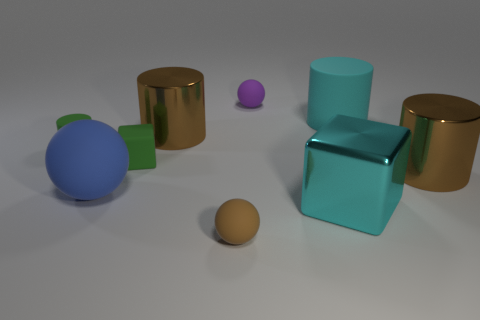Subtract all green cylinders. How many cylinders are left? 3 Subtract 2 balls. How many balls are left? 1 Subtract all green blocks. How many blocks are left? 1 Subtract all red blocks. Subtract all cyan balls. How many blocks are left? 2 Subtract all gray cylinders. How many purple balls are left? 1 Subtract all tiny cylinders. Subtract all big brown shiny objects. How many objects are left? 6 Add 6 green rubber things. How many green rubber things are left? 8 Add 2 brown balls. How many brown balls exist? 3 Subtract 0 green balls. How many objects are left? 9 Subtract all cylinders. How many objects are left? 5 